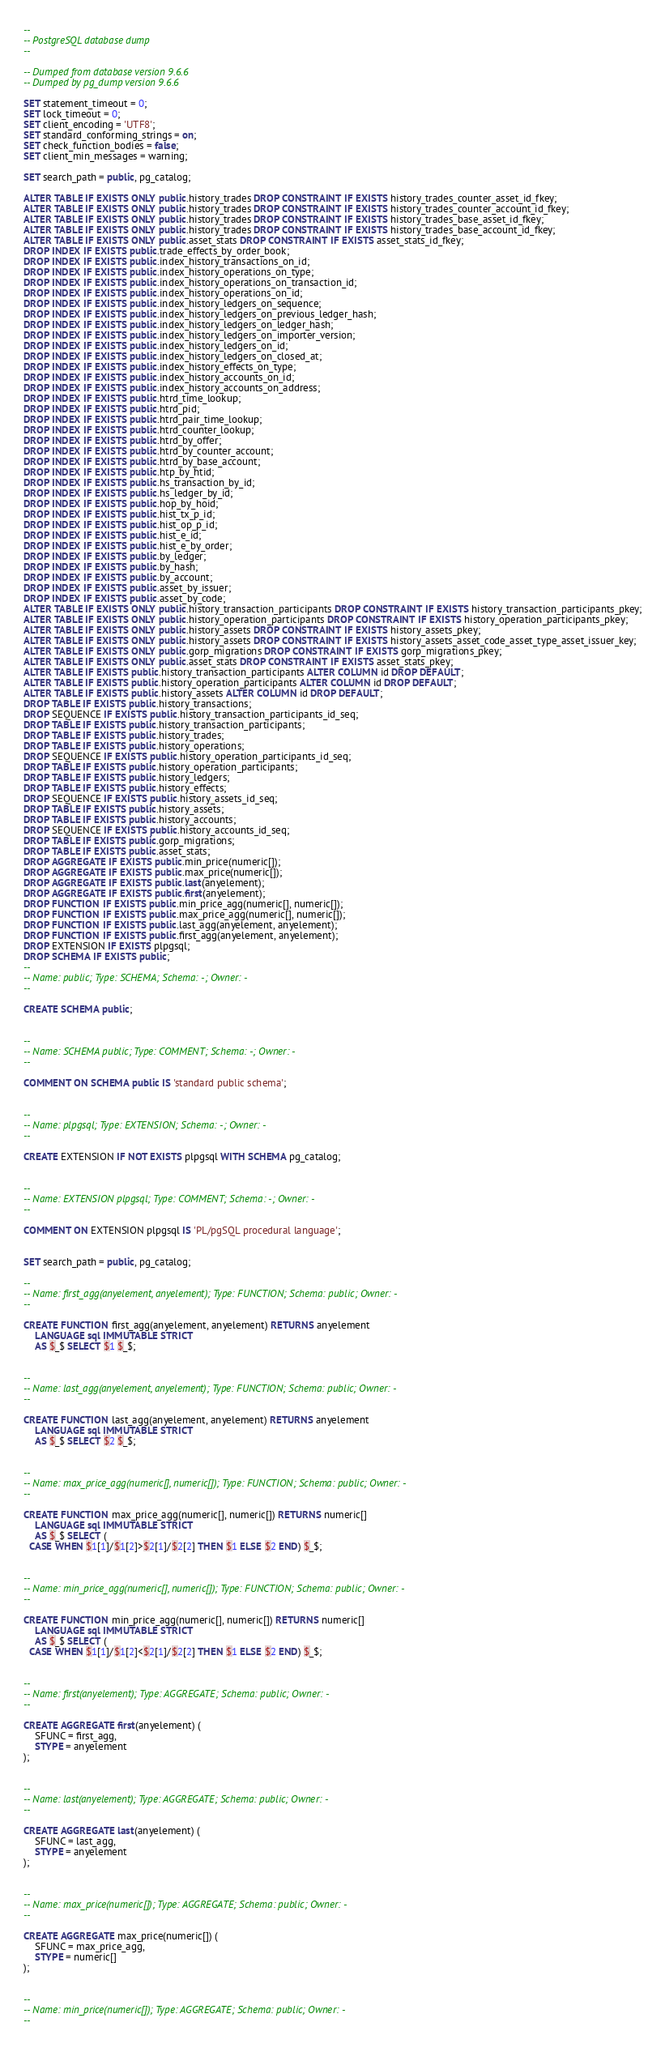<code> <loc_0><loc_0><loc_500><loc_500><_SQL_>--
-- PostgreSQL database dump
--

-- Dumped from database version 9.6.6
-- Dumped by pg_dump version 9.6.6

SET statement_timeout = 0;
SET lock_timeout = 0;
SET client_encoding = 'UTF8';
SET standard_conforming_strings = on;
SET check_function_bodies = false;
SET client_min_messages = warning;

SET search_path = public, pg_catalog;

ALTER TABLE IF EXISTS ONLY public.history_trades DROP CONSTRAINT IF EXISTS history_trades_counter_asset_id_fkey;
ALTER TABLE IF EXISTS ONLY public.history_trades DROP CONSTRAINT IF EXISTS history_trades_counter_account_id_fkey;
ALTER TABLE IF EXISTS ONLY public.history_trades DROP CONSTRAINT IF EXISTS history_trades_base_asset_id_fkey;
ALTER TABLE IF EXISTS ONLY public.history_trades DROP CONSTRAINT IF EXISTS history_trades_base_account_id_fkey;
ALTER TABLE IF EXISTS ONLY public.asset_stats DROP CONSTRAINT IF EXISTS asset_stats_id_fkey;
DROP INDEX IF EXISTS public.trade_effects_by_order_book;
DROP INDEX IF EXISTS public.index_history_transactions_on_id;
DROP INDEX IF EXISTS public.index_history_operations_on_type;
DROP INDEX IF EXISTS public.index_history_operations_on_transaction_id;
DROP INDEX IF EXISTS public.index_history_operations_on_id;
DROP INDEX IF EXISTS public.index_history_ledgers_on_sequence;
DROP INDEX IF EXISTS public.index_history_ledgers_on_previous_ledger_hash;
DROP INDEX IF EXISTS public.index_history_ledgers_on_ledger_hash;
DROP INDEX IF EXISTS public.index_history_ledgers_on_importer_version;
DROP INDEX IF EXISTS public.index_history_ledgers_on_id;
DROP INDEX IF EXISTS public.index_history_ledgers_on_closed_at;
DROP INDEX IF EXISTS public.index_history_effects_on_type;
DROP INDEX IF EXISTS public.index_history_accounts_on_id;
DROP INDEX IF EXISTS public.index_history_accounts_on_address;
DROP INDEX IF EXISTS public.htrd_time_lookup;
DROP INDEX IF EXISTS public.htrd_pid;
DROP INDEX IF EXISTS public.htrd_pair_time_lookup;
DROP INDEX IF EXISTS public.htrd_counter_lookup;
DROP INDEX IF EXISTS public.htrd_by_offer;
DROP INDEX IF EXISTS public.htrd_by_counter_account;
DROP INDEX IF EXISTS public.htrd_by_base_account;
DROP INDEX IF EXISTS public.htp_by_htid;
DROP INDEX IF EXISTS public.hs_transaction_by_id;
DROP INDEX IF EXISTS public.hs_ledger_by_id;
DROP INDEX IF EXISTS public.hop_by_hoid;
DROP INDEX IF EXISTS public.hist_tx_p_id;
DROP INDEX IF EXISTS public.hist_op_p_id;
DROP INDEX IF EXISTS public.hist_e_id;
DROP INDEX IF EXISTS public.hist_e_by_order;
DROP INDEX IF EXISTS public.by_ledger;
DROP INDEX IF EXISTS public.by_hash;
DROP INDEX IF EXISTS public.by_account;
DROP INDEX IF EXISTS public.asset_by_issuer;
DROP INDEX IF EXISTS public.asset_by_code;
ALTER TABLE IF EXISTS ONLY public.history_transaction_participants DROP CONSTRAINT IF EXISTS history_transaction_participants_pkey;
ALTER TABLE IF EXISTS ONLY public.history_operation_participants DROP CONSTRAINT IF EXISTS history_operation_participants_pkey;
ALTER TABLE IF EXISTS ONLY public.history_assets DROP CONSTRAINT IF EXISTS history_assets_pkey;
ALTER TABLE IF EXISTS ONLY public.history_assets DROP CONSTRAINT IF EXISTS history_assets_asset_code_asset_type_asset_issuer_key;
ALTER TABLE IF EXISTS ONLY public.gorp_migrations DROP CONSTRAINT IF EXISTS gorp_migrations_pkey;
ALTER TABLE IF EXISTS ONLY public.asset_stats DROP CONSTRAINT IF EXISTS asset_stats_pkey;
ALTER TABLE IF EXISTS public.history_transaction_participants ALTER COLUMN id DROP DEFAULT;
ALTER TABLE IF EXISTS public.history_operation_participants ALTER COLUMN id DROP DEFAULT;
ALTER TABLE IF EXISTS public.history_assets ALTER COLUMN id DROP DEFAULT;
DROP TABLE IF EXISTS public.history_transactions;
DROP SEQUENCE IF EXISTS public.history_transaction_participants_id_seq;
DROP TABLE IF EXISTS public.history_transaction_participants;
DROP TABLE IF EXISTS public.history_trades;
DROP TABLE IF EXISTS public.history_operations;
DROP SEQUENCE IF EXISTS public.history_operation_participants_id_seq;
DROP TABLE IF EXISTS public.history_operation_participants;
DROP TABLE IF EXISTS public.history_ledgers;
DROP TABLE IF EXISTS public.history_effects;
DROP SEQUENCE IF EXISTS public.history_assets_id_seq;
DROP TABLE IF EXISTS public.history_assets;
DROP TABLE IF EXISTS public.history_accounts;
DROP SEQUENCE IF EXISTS public.history_accounts_id_seq;
DROP TABLE IF EXISTS public.gorp_migrations;
DROP TABLE IF EXISTS public.asset_stats;
DROP AGGREGATE IF EXISTS public.min_price(numeric[]);
DROP AGGREGATE IF EXISTS public.max_price(numeric[]);
DROP AGGREGATE IF EXISTS public.last(anyelement);
DROP AGGREGATE IF EXISTS public.first(anyelement);
DROP FUNCTION IF EXISTS public.min_price_agg(numeric[], numeric[]);
DROP FUNCTION IF EXISTS public.max_price_agg(numeric[], numeric[]);
DROP FUNCTION IF EXISTS public.last_agg(anyelement, anyelement);
DROP FUNCTION IF EXISTS public.first_agg(anyelement, anyelement);
DROP EXTENSION IF EXISTS plpgsql;
DROP SCHEMA IF EXISTS public;
--
-- Name: public; Type: SCHEMA; Schema: -; Owner: -
--

CREATE SCHEMA public;


--
-- Name: SCHEMA public; Type: COMMENT; Schema: -; Owner: -
--

COMMENT ON SCHEMA public IS 'standard public schema';


--
-- Name: plpgsql; Type: EXTENSION; Schema: -; Owner: -
--

CREATE EXTENSION IF NOT EXISTS plpgsql WITH SCHEMA pg_catalog;


--
-- Name: EXTENSION plpgsql; Type: COMMENT; Schema: -; Owner: -
--

COMMENT ON EXTENSION plpgsql IS 'PL/pgSQL procedural language';


SET search_path = public, pg_catalog;

--
-- Name: first_agg(anyelement, anyelement); Type: FUNCTION; Schema: public; Owner: -
--

CREATE FUNCTION first_agg(anyelement, anyelement) RETURNS anyelement
    LANGUAGE sql IMMUTABLE STRICT
    AS $_$ SELECT $1 $_$;


--
-- Name: last_agg(anyelement, anyelement); Type: FUNCTION; Schema: public; Owner: -
--

CREATE FUNCTION last_agg(anyelement, anyelement) RETURNS anyelement
    LANGUAGE sql IMMUTABLE STRICT
    AS $_$ SELECT $2 $_$;


--
-- Name: max_price_agg(numeric[], numeric[]); Type: FUNCTION; Schema: public; Owner: -
--

CREATE FUNCTION max_price_agg(numeric[], numeric[]) RETURNS numeric[]
    LANGUAGE sql IMMUTABLE STRICT
    AS $_$ SELECT (
  CASE WHEN $1[1]/$1[2]>$2[1]/$2[2] THEN $1 ELSE $2 END) $_$;


--
-- Name: min_price_agg(numeric[], numeric[]); Type: FUNCTION; Schema: public; Owner: -
--

CREATE FUNCTION min_price_agg(numeric[], numeric[]) RETURNS numeric[]
    LANGUAGE sql IMMUTABLE STRICT
    AS $_$ SELECT (
  CASE WHEN $1[1]/$1[2]<$2[1]/$2[2] THEN $1 ELSE $2 END) $_$;


--
-- Name: first(anyelement); Type: AGGREGATE; Schema: public; Owner: -
--

CREATE AGGREGATE first(anyelement) (
    SFUNC = first_agg,
    STYPE = anyelement
);


--
-- Name: last(anyelement); Type: AGGREGATE; Schema: public; Owner: -
--

CREATE AGGREGATE last(anyelement) (
    SFUNC = last_agg,
    STYPE = anyelement
);


--
-- Name: max_price(numeric[]); Type: AGGREGATE; Schema: public; Owner: -
--

CREATE AGGREGATE max_price(numeric[]) (
    SFUNC = max_price_agg,
    STYPE = numeric[]
);


--
-- Name: min_price(numeric[]); Type: AGGREGATE; Schema: public; Owner: -
--
</code> 